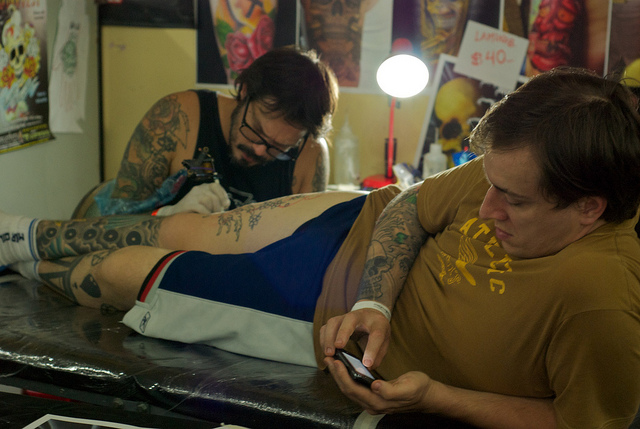What emotion does the man getting tattooed seem to be expressing? The man getting tattooed appears absorbed and slightly tense, likely focusing on his phone to distract himself from the pain typically associated with the tattooing process. Does his body language tell us anything else? His body language, with legs slightly spread and hands preoccupied with his phone, suggests a mix of trying to stay relaxed while also bracing for the discomfort the tattooing might cause. 